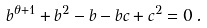Convert formula to latex. <formula><loc_0><loc_0><loc_500><loc_500>b ^ { \theta + 1 } + b ^ { 2 } - b - b c + c ^ { 2 } = 0 \, .</formula> 